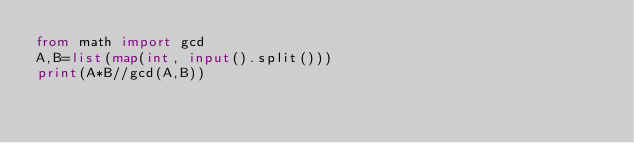<code> <loc_0><loc_0><loc_500><loc_500><_Python_>from math import gcd
A,B=list(map(int, input().split()))
print(A*B//gcd(A,B))</code> 